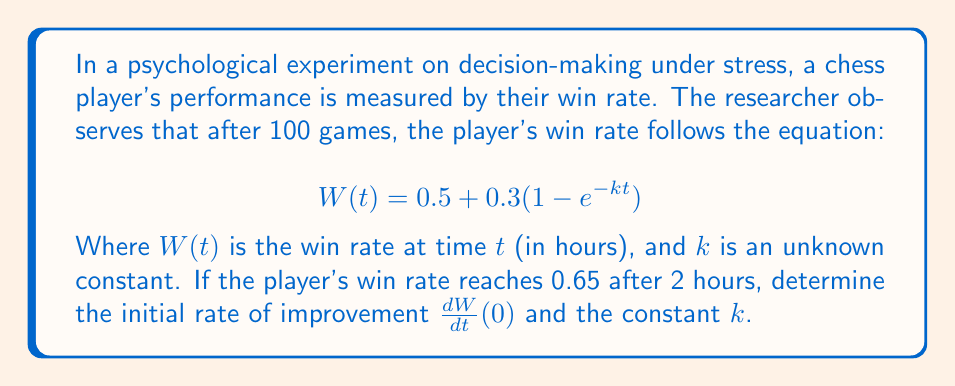Can you solve this math problem? To solve this inverse problem, we'll follow these steps:

1) First, let's find $k$ using the given information:
   At $t = 2$ hours, $W(2) = 0.65$
   
   $$0.65 = 0.5 + 0.3(1 - e^{-2k})$$
   $$0.15 = 0.3(1 - e^{-2k})$$
   $$0.5 = 1 - e^{-2k}$$
   $$e^{-2k} = 0.5$$
   $$-2k = \ln(0.5)$$
   $$k = -\frac{\ln(0.5)}{2} \approx 0.3466$$

2) Now that we have $k$, we can find the initial rate of improvement by taking the derivative of $W(t)$ with respect to $t$ and evaluating it at $t=0$:

   $$\frac{dW}{dt} = 0.3ke^{-kt}$$

   At $t=0$:
   
   $$\frac{dW}{dt}(0) = 0.3k$$

3) Substituting our found value of $k$:

   $$\frac{dW}{dt}(0) = 0.3 \cdot 0.3466 \approx 0.1040$$

This means the initial rate of improvement is about 0.1040 or 10.40% per hour.
Answer: $k \approx 0.3466$, $\frac{dW}{dt}(0) \approx 0.1040$ 